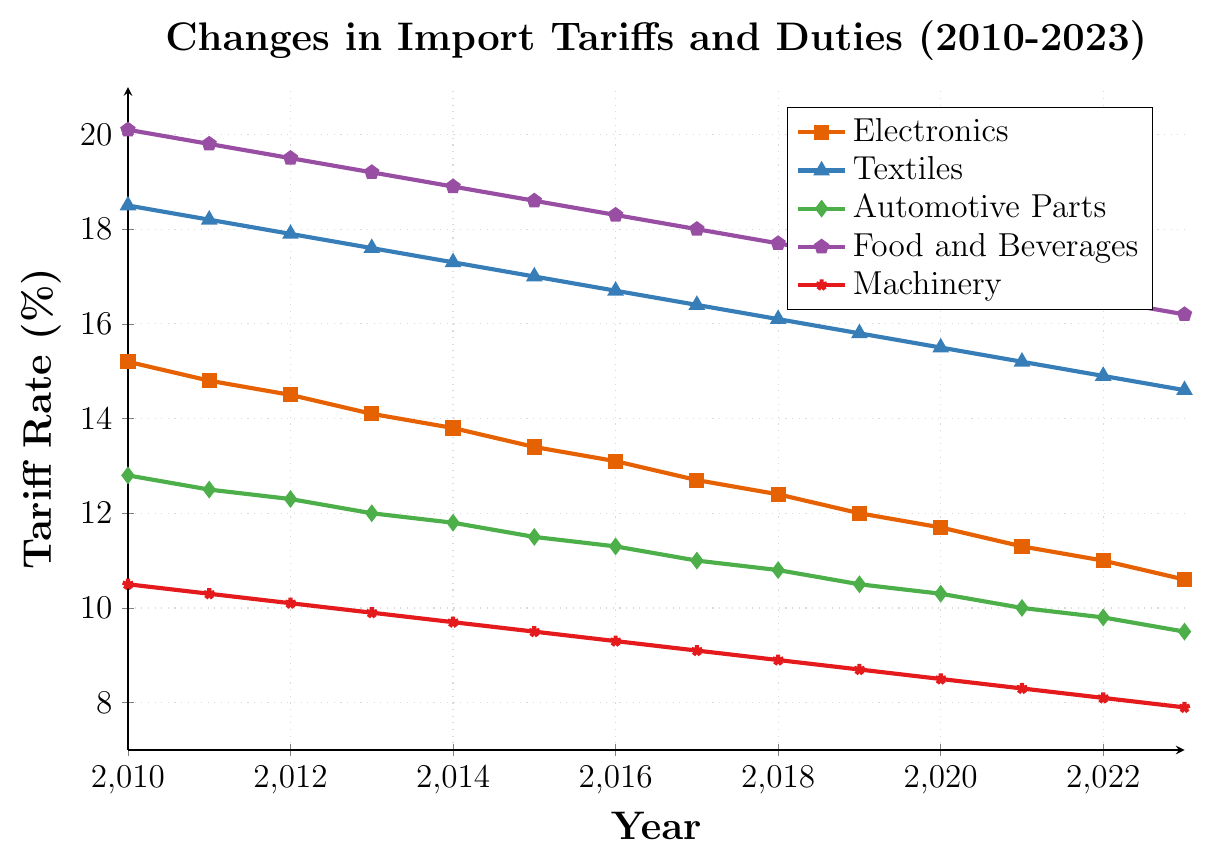What is the trend in import tariffs for Food and Beverages from 2010 to 2023? The trend in import tariffs for Food and Beverages generally shows a gradual decline over the years. Starting from 20.1% in 2010 and decreasing to 16.2% in 2023.
Answer: Downward trend Which product category had the highest import tariffs in 2013? By looking at the plot for the year 2013, we can see that the highest import tariff is for Food and Beverages at 19.2%.
Answer: Food and Beverages Among Electronics and Textiles, which product category experienced a greater decrease in tariff rates from 2010 to 2023? For Electronics: 15.2% (2010) to 10.6% (2023) which is a decrease of 4.6%. For Textiles: 18.5% (2010) to 14.6% (2023) which is a decrease of 3.9%. Therefore, Electronics experienced a greater decrease in tariff rates.
Answer: Electronics What's the average tariff rate for Machinery over the years 2010 to 2023? The tariff rates for Machinery each year from 2010 to 2023 are: (10.5, 10.3, 10.1, 9.9, 9.7, 9.5, 9.3, 9.1, 8.9, 8.7, 8.5, 8.3, 8.1, 7.9). Summing these values gives 139.7. There are 14 years, so the average is 139.7/14 = 9.98.
Answer: 9.98 Did any product category show an increase in tariff rates from 2010 to 2023? By observing all the lines on the chart, none of the product categories show an increase; all categories indicate a reduction in tariff rates from 2010 to 2023.
Answer: No Which product category had the smallest tariff rate in 2020? By looking at the plot for the year 2020, it is evident that Machinery had the smallest tariff rate at 8.5%.
Answer: Machinery What is the difference in tariff rates for Automotive Parts between 2015 and 2023? The tariff rate for Automotive Parts in 2015 is 11.5% and in 2023 is 9.5%. The difference is 11.5% - 9.5% = 2.0%.
Answer: 2.0% How do the tariffs for Textiles in 2012 compare to those in 2022? The tariff rate for Textiles in 2012 is 17.9% and in 2022 is 14.9%. Thus, the tariff rate decreased by 17.9% - 14.9% = 3.0%.
Answer: 3.0% decrease What's the overall percentage drop in import tariffs for Electronics from 2010 to 2023? The tariff rate for Electronics in 2010 is 15.2% and in 2023 is 10.6%. The percentage drop is calculated as ((15.2 - 10.6) / 15.2) * 100 = 30.26%.
Answer: 30.26% Which year had the highest overall tariffs across all categories? By observing the plot, 2010 has the highest tariffs across all categories compared to other years.
Answer: 2010 